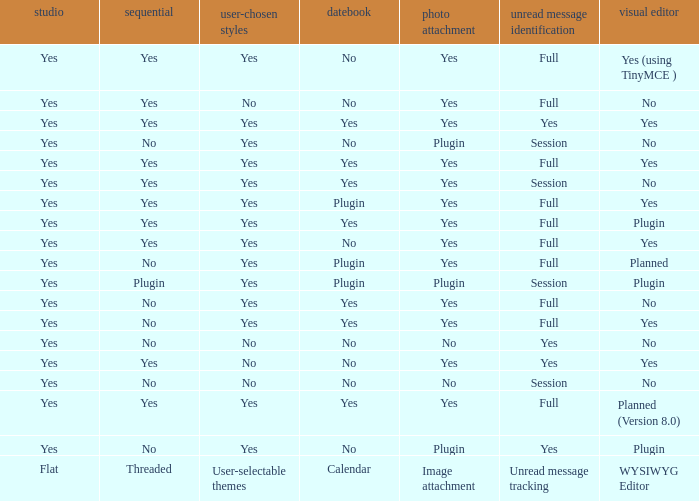Which Calendar has a User-selectable themes of user-selectable themes? Calendar. 